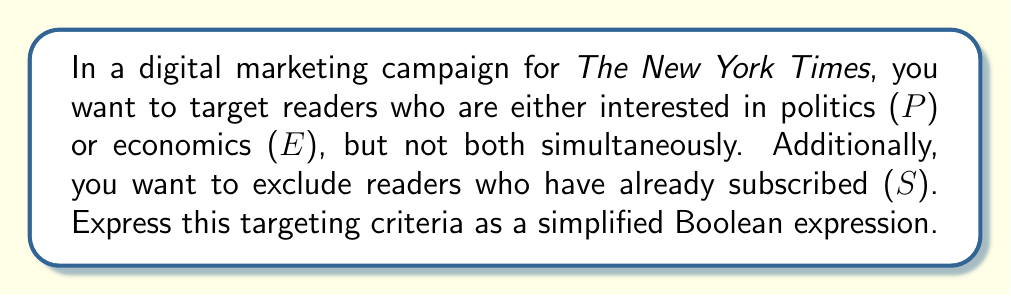What is the answer to this math problem? Let's approach this step-by-step:

1) First, we need to express "interested in politics or economics, but not both":
   This is an exclusive OR (XOR) operation, which can be written as:
   $$(P \wedge \neg E) \vee (\neg P \wedge E)$$

2) Now, we need to exclude subscribers. This means we want the above expression to be true AND the reader should not be a subscriber:
   $$((P \wedge \neg E) \vee (\neg P \wedge E)) \wedge \neg S$$

3) Let's simplify this expression using Boolean algebra laws:
   $$((P \wedge \neg E) \vee (\neg P \wedge E)) \wedge \neg S$$
   $$= (P \wedge \neg E \wedge \neg S) \vee (\neg P \wedge E \wedge \neg S)$$  (Distributive law)

4) This expression can't be simplified further using Boolean algebra. However, in the context of digital marketing, we can represent this as:
   $$(P \oplus E) \wedge \neg S$$

   Where $\oplus$ represents the XOR operation.

This simplified form clearly shows we're targeting readers interested in either politics or economics (but not both), and who are not subscribers.
Answer: $$(P \oplus E) \wedge \neg S$$ 